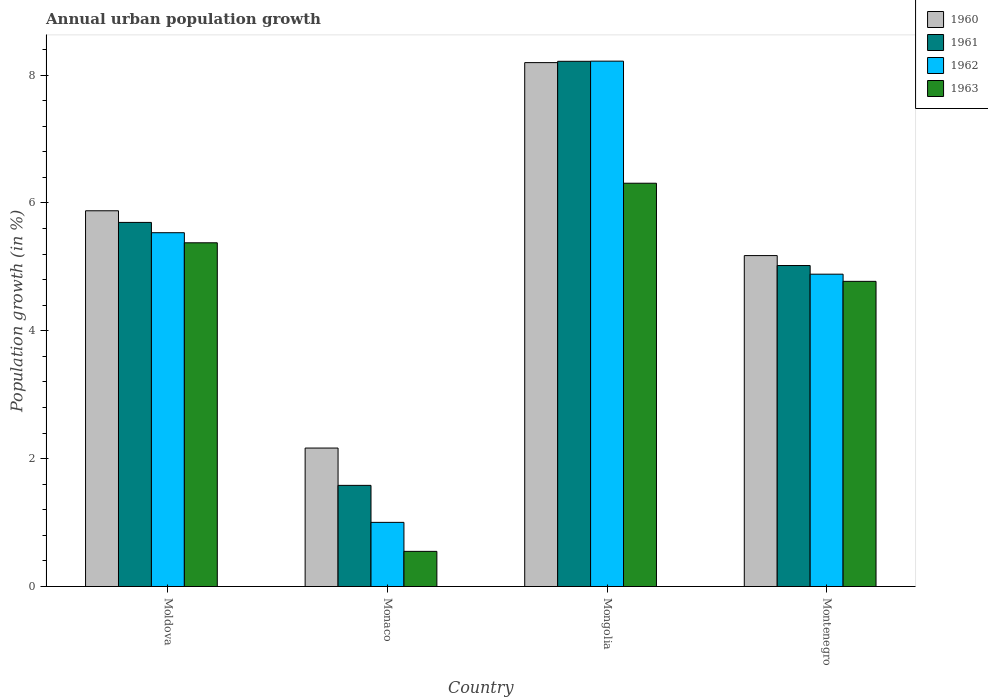How many groups of bars are there?
Give a very brief answer. 4. What is the label of the 3rd group of bars from the left?
Make the answer very short. Mongolia. What is the percentage of urban population growth in 1963 in Montenegro?
Provide a short and direct response. 4.77. Across all countries, what is the maximum percentage of urban population growth in 1960?
Your answer should be compact. 8.19. Across all countries, what is the minimum percentage of urban population growth in 1962?
Offer a very short reply. 1. In which country was the percentage of urban population growth in 1962 maximum?
Provide a short and direct response. Mongolia. In which country was the percentage of urban population growth in 1963 minimum?
Give a very brief answer. Monaco. What is the total percentage of urban population growth in 1963 in the graph?
Keep it short and to the point. 17.01. What is the difference between the percentage of urban population growth in 1961 in Monaco and that in Montenegro?
Make the answer very short. -3.44. What is the difference between the percentage of urban population growth in 1961 in Mongolia and the percentage of urban population growth in 1962 in Moldova?
Your response must be concise. 2.68. What is the average percentage of urban population growth in 1960 per country?
Your answer should be very brief. 5.35. What is the difference between the percentage of urban population growth of/in 1961 and percentage of urban population growth of/in 1963 in Monaco?
Your answer should be very brief. 1.03. What is the ratio of the percentage of urban population growth in 1960 in Moldova to that in Monaco?
Offer a very short reply. 2.71. Is the percentage of urban population growth in 1963 in Moldova less than that in Monaco?
Provide a short and direct response. No. What is the difference between the highest and the second highest percentage of urban population growth in 1962?
Your answer should be compact. 3.33. What is the difference between the highest and the lowest percentage of urban population growth in 1962?
Offer a very short reply. 7.21. What does the 4th bar from the left in Montenegro represents?
Offer a terse response. 1963. What is the difference between two consecutive major ticks on the Y-axis?
Provide a succinct answer. 2. Does the graph contain any zero values?
Offer a terse response. No. Does the graph contain grids?
Keep it short and to the point. No. Where does the legend appear in the graph?
Give a very brief answer. Top right. How many legend labels are there?
Offer a very short reply. 4. What is the title of the graph?
Offer a terse response. Annual urban population growth. What is the label or title of the Y-axis?
Offer a very short reply. Population growth (in %). What is the Population growth (in %) in 1960 in Moldova?
Your response must be concise. 5.88. What is the Population growth (in %) in 1961 in Moldova?
Offer a terse response. 5.69. What is the Population growth (in %) of 1962 in Moldova?
Provide a succinct answer. 5.53. What is the Population growth (in %) of 1963 in Moldova?
Provide a succinct answer. 5.38. What is the Population growth (in %) of 1960 in Monaco?
Offer a terse response. 2.17. What is the Population growth (in %) in 1961 in Monaco?
Give a very brief answer. 1.58. What is the Population growth (in %) of 1962 in Monaco?
Offer a terse response. 1. What is the Population growth (in %) of 1963 in Monaco?
Give a very brief answer. 0.55. What is the Population growth (in %) of 1960 in Mongolia?
Make the answer very short. 8.19. What is the Population growth (in %) of 1961 in Mongolia?
Your response must be concise. 8.21. What is the Population growth (in %) of 1962 in Mongolia?
Keep it short and to the point. 8.22. What is the Population growth (in %) of 1963 in Mongolia?
Keep it short and to the point. 6.31. What is the Population growth (in %) in 1960 in Montenegro?
Your answer should be very brief. 5.18. What is the Population growth (in %) in 1961 in Montenegro?
Your response must be concise. 5.02. What is the Population growth (in %) in 1962 in Montenegro?
Give a very brief answer. 4.89. What is the Population growth (in %) of 1963 in Montenegro?
Provide a short and direct response. 4.77. Across all countries, what is the maximum Population growth (in %) in 1960?
Provide a short and direct response. 8.19. Across all countries, what is the maximum Population growth (in %) in 1961?
Your answer should be compact. 8.21. Across all countries, what is the maximum Population growth (in %) in 1962?
Your response must be concise. 8.22. Across all countries, what is the maximum Population growth (in %) in 1963?
Provide a short and direct response. 6.31. Across all countries, what is the minimum Population growth (in %) of 1960?
Your response must be concise. 2.17. Across all countries, what is the minimum Population growth (in %) in 1961?
Ensure brevity in your answer.  1.58. Across all countries, what is the minimum Population growth (in %) in 1962?
Your answer should be very brief. 1. Across all countries, what is the minimum Population growth (in %) in 1963?
Keep it short and to the point. 0.55. What is the total Population growth (in %) in 1960 in the graph?
Ensure brevity in your answer.  21.41. What is the total Population growth (in %) in 1961 in the graph?
Provide a succinct answer. 20.51. What is the total Population growth (in %) of 1962 in the graph?
Your answer should be very brief. 19.64. What is the total Population growth (in %) in 1963 in the graph?
Your answer should be compact. 17.01. What is the difference between the Population growth (in %) of 1960 in Moldova and that in Monaco?
Provide a short and direct response. 3.71. What is the difference between the Population growth (in %) of 1961 in Moldova and that in Monaco?
Your answer should be very brief. 4.11. What is the difference between the Population growth (in %) of 1962 in Moldova and that in Monaco?
Offer a terse response. 4.53. What is the difference between the Population growth (in %) in 1963 in Moldova and that in Monaco?
Your response must be concise. 4.83. What is the difference between the Population growth (in %) in 1960 in Moldova and that in Mongolia?
Provide a short and direct response. -2.32. What is the difference between the Population growth (in %) in 1961 in Moldova and that in Mongolia?
Provide a succinct answer. -2.52. What is the difference between the Population growth (in %) in 1962 in Moldova and that in Mongolia?
Give a very brief answer. -2.68. What is the difference between the Population growth (in %) in 1963 in Moldova and that in Mongolia?
Provide a succinct answer. -0.93. What is the difference between the Population growth (in %) in 1960 in Moldova and that in Montenegro?
Offer a very short reply. 0.7. What is the difference between the Population growth (in %) of 1961 in Moldova and that in Montenegro?
Provide a succinct answer. 0.67. What is the difference between the Population growth (in %) in 1962 in Moldova and that in Montenegro?
Offer a terse response. 0.65. What is the difference between the Population growth (in %) in 1963 in Moldova and that in Montenegro?
Your answer should be very brief. 0.6. What is the difference between the Population growth (in %) of 1960 in Monaco and that in Mongolia?
Keep it short and to the point. -6.03. What is the difference between the Population growth (in %) of 1961 in Monaco and that in Mongolia?
Your response must be concise. -6.63. What is the difference between the Population growth (in %) in 1962 in Monaco and that in Mongolia?
Provide a succinct answer. -7.21. What is the difference between the Population growth (in %) in 1963 in Monaco and that in Mongolia?
Keep it short and to the point. -5.76. What is the difference between the Population growth (in %) in 1960 in Monaco and that in Montenegro?
Provide a short and direct response. -3.01. What is the difference between the Population growth (in %) of 1961 in Monaco and that in Montenegro?
Your answer should be compact. -3.44. What is the difference between the Population growth (in %) of 1962 in Monaco and that in Montenegro?
Your response must be concise. -3.88. What is the difference between the Population growth (in %) in 1963 in Monaco and that in Montenegro?
Offer a very short reply. -4.22. What is the difference between the Population growth (in %) in 1960 in Mongolia and that in Montenegro?
Your response must be concise. 3.02. What is the difference between the Population growth (in %) in 1961 in Mongolia and that in Montenegro?
Keep it short and to the point. 3.19. What is the difference between the Population growth (in %) in 1962 in Mongolia and that in Montenegro?
Offer a terse response. 3.33. What is the difference between the Population growth (in %) in 1963 in Mongolia and that in Montenegro?
Offer a very short reply. 1.53. What is the difference between the Population growth (in %) in 1960 in Moldova and the Population growth (in %) in 1961 in Monaco?
Your answer should be compact. 4.29. What is the difference between the Population growth (in %) in 1960 in Moldova and the Population growth (in %) in 1962 in Monaco?
Provide a succinct answer. 4.87. What is the difference between the Population growth (in %) of 1960 in Moldova and the Population growth (in %) of 1963 in Monaco?
Offer a terse response. 5.33. What is the difference between the Population growth (in %) of 1961 in Moldova and the Population growth (in %) of 1962 in Monaco?
Keep it short and to the point. 4.69. What is the difference between the Population growth (in %) in 1961 in Moldova and the Population growth (in %) in 1963 in Monaco?
Your response must be concise. 5.15. What is the difference between the Population growth (in %) of 1962 in Moldova and the Population growth (in %) of 1963 in Monaco?
Offer a terse response. 4.98. What is the difference between the Population growth (in %) of 1960 in Moldova and the Population growth (in %) of 1961 in Mongolia?
Offer a very short reply. -2.34. What is the difference between the Population growth (in %) in 1960 in Moldova and the Population growth (in %) in 1962 in Mongolia?
Provide a short and direct response. -2.34. What is the difference between the Population growth (in %) of 1960 in Moldova and the Population growth (in %) of 1963 in Mongolia?
Make the answer very short. -0.43. What is the difference between the Population growth (in %) in 1961 in Moldova and the Population growth (in %) in 1962 in Mongolia?
Provide a succinct answer. -2.52. What is the difference between the Population growth (in %) in 1961 in Moldova and the Population growth (in %) in 1963 in Mongolia?
Your answer should be compact. -0.61. What is the difference between the Population growth (in %) of 1962 in Moldova and the Population growth (in %) of 1963 in Mongolia?
Give a very brief answer. -0.77. What is the difference between the Population growth (in %) in 1960 in Moldova and the Population growth (in %) in 1961 in Montenegro?
Your answer should be very brief. 0.86. What is the difference between the Population growth (in %) in 1960 in Moldova and the Population growth (in %) in 1962 in Montenegro?
Provide a short and direct response. 0.99. What is the difference between the Population growth (in %) in 1960 in Moldova and the Population growth (in %) in 1963 in Montenegro?
Offer a very short reply. 1.1. What is the difference between the Population growth (in %) of 1961 in Moldova and the Population growth (in %) of 1962 in Montenegro?
Make the answer very short. 0.81. What is the difference between the Population growth (in %) in 1961 in Moldova and the Population growth (in %) in 1963 in Montenegro?
Offer a very short reply. 0.92. What is the difference between the Population growth (in %) in 1962 in Moldova and the Population growth (in %) in 1963 in Montenegro?
Your answer should be compact. 0.76. What is the difference between the Population growth (in %) in 1960 in Monaco and the Population growth (in %) in 1961 in Mongolia?
Your response must be concise. -6.05. What is the difference between the Population growth (in %) of 1960 in Monaco and the Population growth (in %) of 1962 in Mongolia?
Your answer should be very brief. -6.05. What is the difference between the Population growth (in %) in 1960 in Monaco and the Population growth (in %) in 1963 in Mongolia?
Your answer should be very brief. -4.14. What is the difference between the Population growth (in %) in 1961 in Monaco and the Population growth (in %) in 1962 in Mongolia?
Your response must be concise. -6.64. What is the difference between the Population growth (in %) in 1961 in Monaco and the Population growth (in %) in 1963 in Mongolia?
Give a very brief answer. -4.73. What is the difference between the Population growth (in %) of 1962 in Monaco and the Population growth (in %) of 1963 in Mongolia?
Your response must be concise. -5.3. What is the difference between the Population growth (in %) of 1960 in Monaco and the Population growth (in %) of 1961 in Montenegro?
Provide a succinct answer. -2.85. What is the difference between the Population growth (in %) of 1960 in Monaco and the Population growth (in %) of 1962 in Montenegro?
Give a very brief answer. -2.72. What is the difference between the Population growth (in %) of 1960 in Monaco and the Population growth (in %) of 1963 in Montenegro?
Keep it short and to the point. -2.61. What is the difference between the Population growth (in %) of 1961 in Monaco and the Population growth (in %) of 1962 in Montenegro?
Make the answer very short. -3.3. What is the difference between the Population growth (in %) of 1961 in Monaco and the Population growth (in %) of 1963 in Montenegro?
Give a very brief answer. -3.19. What is the difference between the Population growth (in %) in 1962 in Monaco and the Population growth (in %) in 1963 in Montenegro?
Your answer should be compact. -3.77. What is the difference between the Population growth (in %) in 1960 in Mongolia and the Population growth (in %) in 1961 in Montenegro?
Offer a terse response. 3.17. What is the difference between the Population growth (in %) of 1960 in Mongolia and the Population growth (in %) of 1962 in Montenegro?
Your answer should be very brief. 3.31. What is the difference between the Population growth (in %) of 1960 in Mongolia and the Population growth (in %) of 1963 in Montenegro?
Offer a very short reply. 3.42. What is the difference between the Population growth (in %) of 1961 in Mongolia and the Population growth (in %) of 1962 in Montenegro?
Your response must be concise. 3.33. What is the difference between the Population growth (in %) in 1961 in Mongolia and the Population growth (in %) in 1963 in Montenegro?
Make the answer very short. 3.44. What is the difference between the Population growth (in %) in 1962 in Mongolia and the Population growth (in %) in 1963 in Montenegro?
Your answer should be compact. 3.44. What is the average Population growth (in %) of 1960 per country?
Provide a succinct answer. 5.35. What is the average Population growth (in %) of 1961 per country?
Give a very brief answer. 5.13. What is the average Population growth (in %) of 1962 per country?
Make the answer very short. 4.91. What is the average Population growth (in %) of 1963 per country?
Make the answer very short. 4.25. What is the difference between the Population growth (in %) of 1960 and Population growth (in %) of 1961 in Moldova?
Provide a succinct answer. 0.18. What is the difference between the Population growth (in %) in 1960 and Population growth (in %) in 1962 in Moldova?
Your answer should be compact. 0.34. What is the difference between the Population growth (in %) in 1960 and Population growth (in %) in 1963 in Moldova?
Give a very brief answer. 0.5. What is the difference between the Population growth (in %) in 1961 and Population growth (in %) in 1962 in Moldova?
Your answer should be compact. 0.16. What is the difference between the Population growth (in %) of 1961 and Population growth (in %) of 1963 in Moldova?
Provide a short and direct response. 0.32. What is the difference between the Population growth (in %) in 1962 and Population growth (in %) in 1963 in Moldova?
Your response must be concise. 0.16. What is the difference between the Population growth (in %) in 1960 and Population growth (in %) in 1961 in Monaco?
Ensure brevity in your answer.  0.58. What is the difference between the Population growth (in %) in 1960 and Population growth (in %) in 1962 in Monaco?
Keep it short and to the point. 1.16. What is the difference between the Population growth (in %) of 1960 and Population growth (in %) of 1963 in Monaco?
Provide a succinct answer. 1.62. What is the difference between the Population growth (in %) in 1961 and Population growth (in %) in 1962 in Monaco?
Your response must be concise. 0.58. What is the difference between the Population growth (in %) of 1961 and Population growth (in %) of 1963 in Monaco?
Give a very brief answer. 1.03. What is the difference between the Population growth (in %) in 1962 and Population growth (in %) in 1963 in Monaco?
Your answer should be compact. 0.45. What is the difference between the Population growth (in %) in 1960 and Population growth (in %) in 1961 in Mongolia?
Provide a succinct answer. -0.02. What is the difference between the Population growth (in %) of 1960 and Population growth (in %) of 1962 in Mongolia?
Keep it short and to the point. -0.02. What is the difference between the Population growth (in %) in 1960 and Population growth (in %) in 1963 in Mongolia?
Your answer should be very brief. 1.89. What is the difference between the Population growth (in %) of 1961 and Population growth (in %) of 1962 in Mongolia?
Keep it short and to the point. -0. What is the difference between the Population growth (in %) in 1961 and Population growth (in %) in 1963 in Mongolia?
Your answer should be compact. 1.91. What is the difference between the Population growth (in %) of 1962 and Population growth (in %) of 1963 in Mongolia?
Provide a succinct answer. 1.91. What is the difference between the Population growth (in %) in 1960 and Population growth (in %) in 1961 in Montenegro?
Keep it short and to the point. 0.16. What is the difference between the Population growth (in %) in 1960 and Population growth (in %) in 1962 in Montenegro?
Give a very brief answer. 0.29. What is the difference between the Population growth (in %) in 1960 and Population growth (in %) in 1963 in Montenegro?
Provide a succinct answer. 0.4. What is the difference between the Population growth (in %) of 1961 and Population growth (in %) of 1962 in Montenegro?
Give a very brief answer. 0.14. What is the difference between the Population growth (in %) of 1961 and Population growth (in %) of 1963 in Montenegro?
Your answer should be compact. 0.25. What is the difference between the Population growth (in %) in 1962 and Population growth (in %) in 1963 in Montenegro?
Your answer should be compact. 0.11. What is the ratio of the Population growth (in %) of 1960 in Moldova to that in Monaco?
Your answer should be very brief. 2.71. What is the ratio of the Population growth (in %) in 1961 in Moldova to that in Monaco?
Keep it short and to the point. 3.6. What is the ratio of the Population growth (in %) in 1962 in Moldova to that in Monaco?
Keep it short and to the point. 5.52. What is the ratio of the Population growth (in %) of 1963 in Moldova to that in Monaco?
Provide a short and direct response. 9.78. What is the ratio of the Population growth (in %) in 1960 in Moldova to that in Mongolia?
Ensure brevity in your answer.  0.72. What is the ratio of the Population growth (in %) in 1961 in Moldova to that in Mongolia?
Provide a succinct answer. 0.69. What is the ratio of the Population growth (in %) in 1962 in Moldova to that in Mongolia?
Provide a succinct answer. 0.67. What is the ratio of the Population growth (in %) of 1963 in Moldova to that in Mongolia?
Provide a succinct answer. 0.85. What is the ratio of the Population growth (in %) of 1960 in Moldova to that in Montenegro?
Your answer should be very brief. 1.14. What is the ratio of the Population growth (in %) of 1961 in Moldova to that in Montenegro?
Offer a very short reply. 1.13. What is the ratio of the Population growth (in %) of 1962 in Moldova to that in Montenegro?
Offer a very short reply. 1.13. What is the ratio of the Population growth (in %) in 1963 in Moldova to that in Montenegro?
Your answer should be very brief. 1.13. What is the ratio of the Population growth (in %) of 1960 in Monaco to that in Mongolia?
Keep it short and to the point. 0.26. What is the ratio of the Population growth (in %) of 1961 in Monaco to that in Mongolia?
Your answer should be very brief. 0.19. What is the ratio of the Population growth (in %) in 1962 in Monaco to that in Mongolia?
Your answer should be compact. 0.12. What is the ratio of the Population growth (in %) of 1963 in Monaco to that in Mongolia?
Your answer should be very brief. 0.09. What is the ratio of the Population growth (in %) in 1960 in Monaco to that in Montenegro?
Provide a short and direct response. 0.42. What is the ratio of the Population growth (in %) of 1961 in Monaco to that in Montenegro?
Ensure brevity in your answer.  0.32. What is the ratio of the Population growth (in %) of 1962 in Monaco to that in Montenegro?
Offer a terse response. 0.21. What is the ratio of the Population growth (in %) of 1963 in Monaco to that in Montenegro?
Provide a short and direct response. 0.12. What is the ratio of the Population growth (in %) of 1960 in Mongolia to that in Montenegro?
Offer a terse response. 1.58. What is the ratio of the Population growth (in %) of 1961 in Mongolia to that in Montenegro?
Ensure brevity in your answer.  1.64. What is the ratio of the Population growth (in %) in 1962 in Mongolia to that in Montenegro?
Provide a succinct answer. 1.68. What is the ratio of the Population growth (in %) of 1963 in Mongolia to that in Montenegro?
Keep it short and to the point. 1.32. What is the difference between the highest and the second highest Population growth (in %) of 1960?
Provide a succinct answer. 2.32. What is the difference between the highest and the second highest Population growth (in %) in 1961?
Offer a very short reply. 2.52. What is the difference between the highest and the second highest Population growth (in %) of 1962?
Your answer should be very brief. 2.68. What is the difference between the highest and the second highest Population growth (in %) of 1963?
Your answer should be compact. 0.93. What is the difference between the highest and the lowest Population growth (in %) in 1960?
Provide a short and direct response. 6.03. What is the difference between the highest and the lowest Population growth (in %) in 1961?
Your response must be concise. 6.63. What is the difference between the highest and the lowest Population growth (in %) in 1962?
Offer a very short reply. 7.21. What is the difference between the highest and the lowest Population growth (in %) in 1963?
Your answer should be compact. 5.76. 